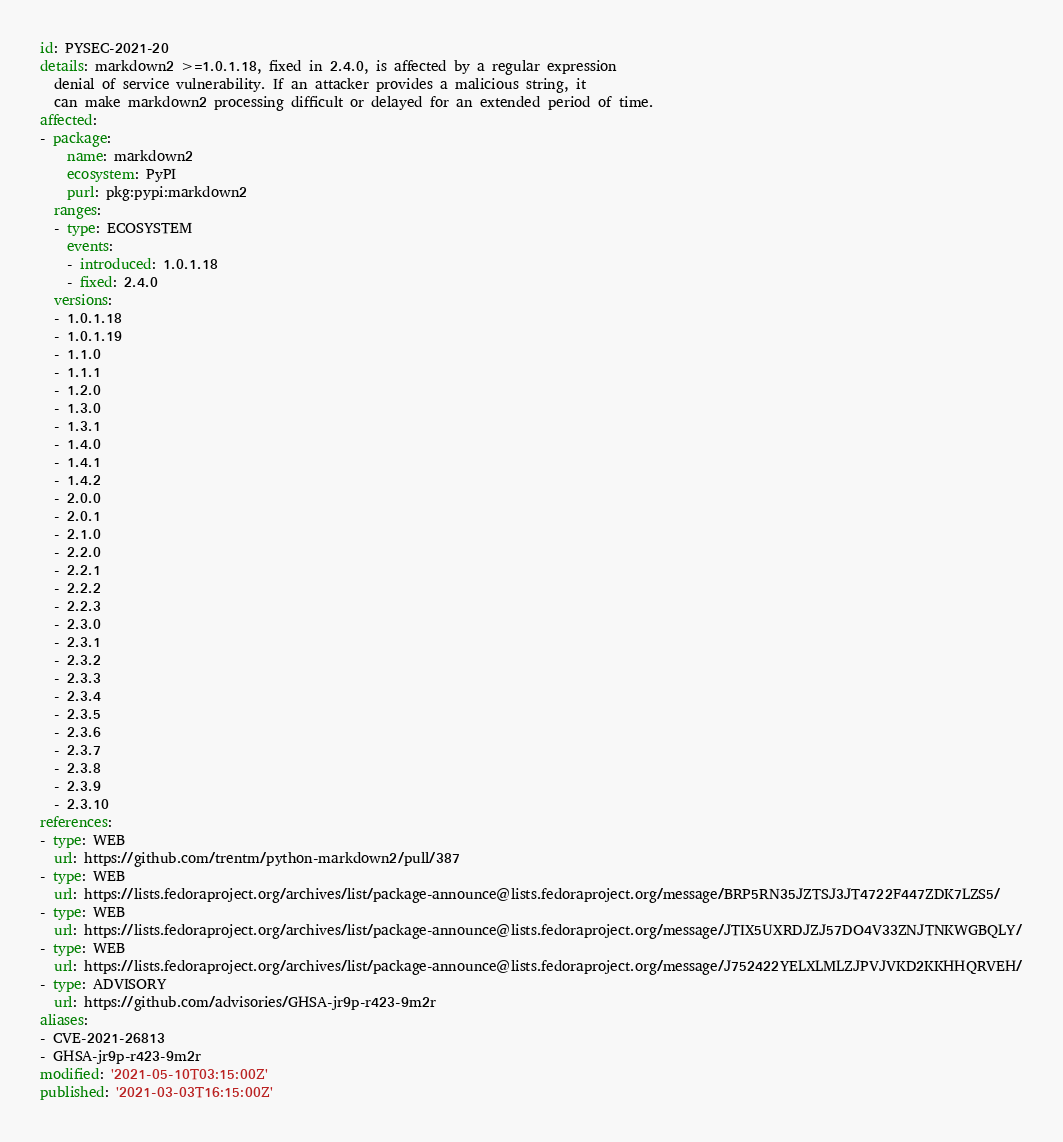<code> <loc_0><loc_0><loc_500><loc_500><_YAML_>id: PYSEC-2021-20
details: markdown2 >=1.0.1.18, fixed in 2.4.0, is affected by a regular expression
  denial of service vulnerability. If an attacker provides a malicious string, it
  can make markdown2 processing difficult or delayed for an extended period of time.
affected:
- package:
    name: markdown2
    ecosystem: PyPI
    purl: pkg:pypi:markdown2
  ranges:
  - type: ECOSYSTEM
    events:
    - introduced: 1.0.1.18
    - fixed: 2.4.0
  versions:
  - 1.0.1.18
  - 1.0.1.19
  - 1.1.0
  - 1.1.1
  - 1.2.0
  - 1.3.0
  - 1.3.1
  - 1.4.0
  - 1.4.1
  - 1.4.2
  - 2.0.0
  - 2.0.1
  - 2.1.0
  - 2.2.0
  - 2.2.1
  - 2.2.2
  - 2.2.3
  - 2.3.0
  - 2.3.1
  - 2.3.2
  - 2.3.3
  - 2.3.4
  - 2.3.5
  - 2.3.6
  - 2.3.7
  - 2.3.8
  - 2.3.9
  - 2.3.10
references:
- type: WEB
  url: https://github.com/trentm/python-markdown2/pull/387
- type: WEB
  url: https://lists.fedoraproject.org/archives/list/package-announce@lists.fedoraproject.org/message/BRP5RN35JZTSJ3JT4722F447ZDK7LZS5/
- type: WEB
  url: https://lists.fedoraproject.org/archives/list/package-announce@lists.fedoraproject.org/message/JTIX5UXRDJZJ57DO4V33ZNJTNKWGBQLY/
- type: WEB
  url: https://lists.fedoraproject.org/archives/list/package-announce@lists.fedoraproject.org/message/J752422YELXLMLZJPVJVKD2KKHHQRVEH/
- type: ADVISORY
  url: https://github.com/advisories/GHSA-jr9p-r423-9m2r
aliases:
- CVE-2021-26813
- GHSA-jr9p-r423-9m2r
modified: '2021-05-10T03:15:00Z'
published: '2021-03-03T16:15:00Z'
</code> 